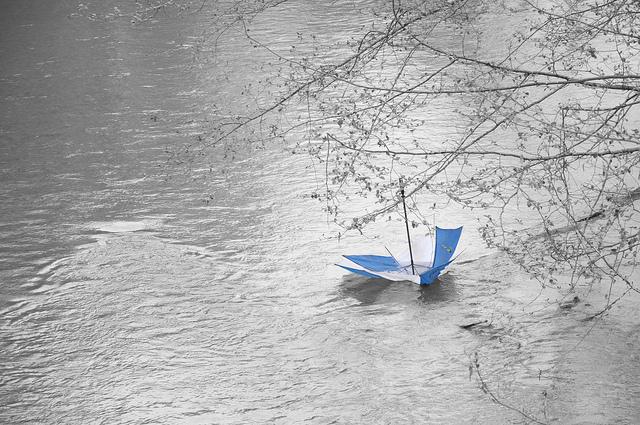What color is the umbrella?
Be succinct. Blue and white. What color is the water?
Quick response, please. Gray. Is it wet outside?
Give a very brief answer. Yes. What is in the water?
Give a very brief answer. Umbrella. 